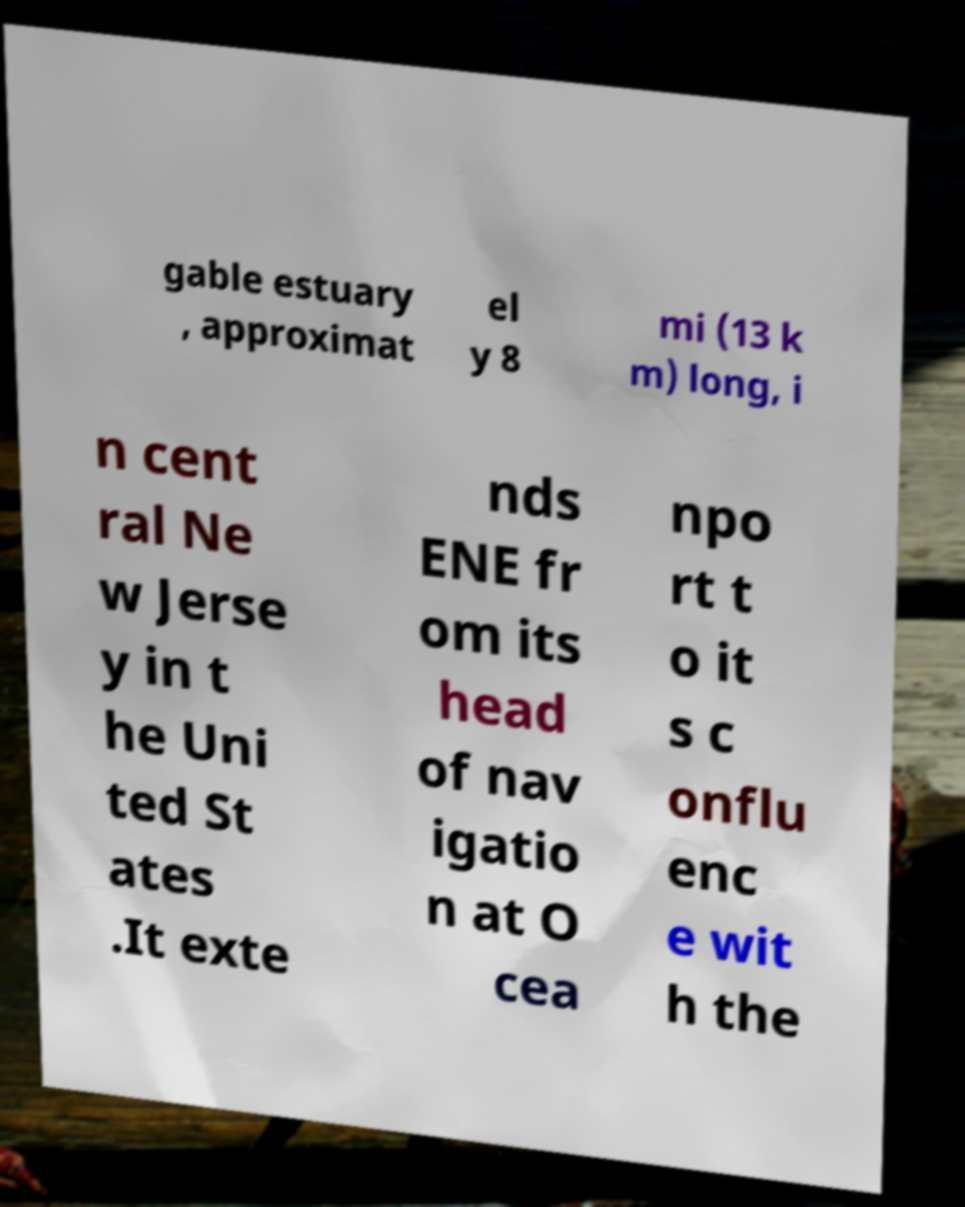Could you assist in decoding the text presented in this image and type it out clearly? gable estuary , approximat el y 8 mi (13 k m) long, i n cent ral Ne w Jerse y in t he Uni ted St ates .It exte nds ENE fr om its head of nav igatio n at O cea npo rt t o it s c onflu enc e wit h the 